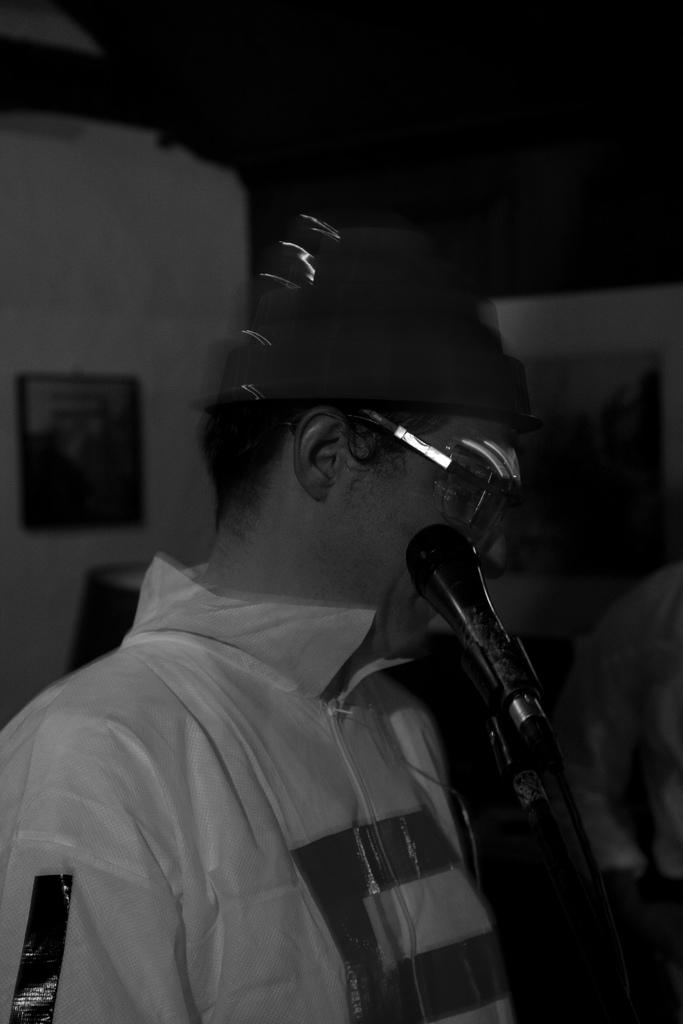What is the person in the image doing? The person is standing in the image and holding a microphone. What else can be seen in the image besides the person? There is a photo frame visible in the image. What is the color scheme of the image? The image is black and white. Is there a flame visible in the image? No, there is no flame present in the image. What is the value of the microphone in the image? The value of the microphone cannot be determined from the image alone. 